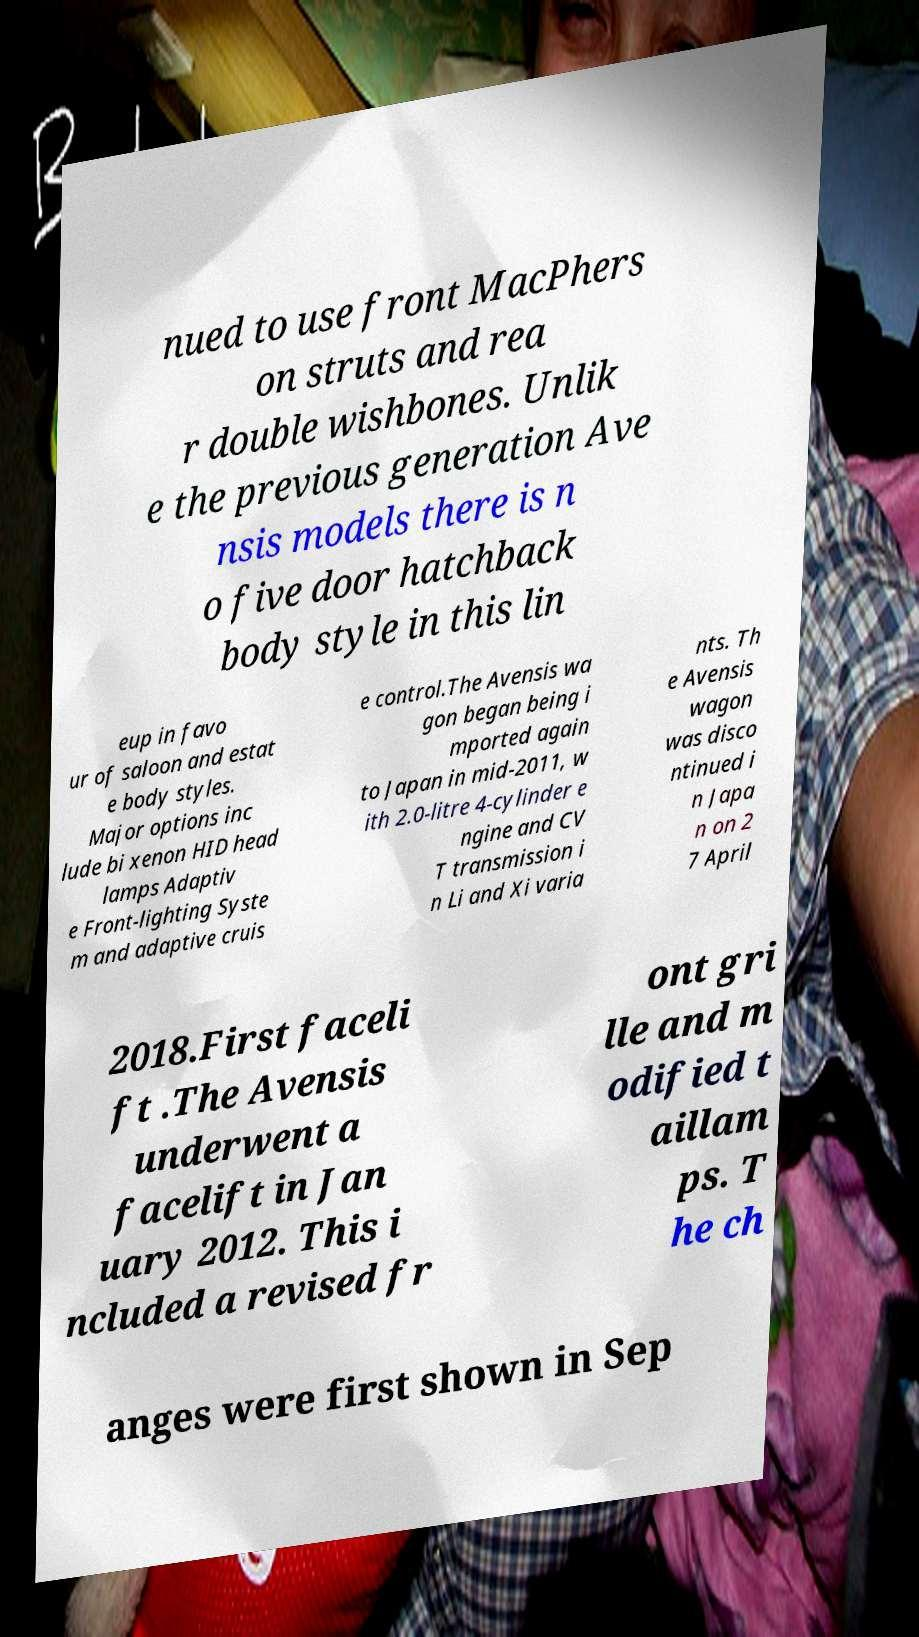Could you extract and type out the text from this image? nued to use front MacPhers on struts and rea r double wishbones. Unlik e the previous generation Ave nsis models there is n o five door hatchback body style in this lin eup in favo ur of saloon and estat e body styles. Major options inc lude bi xenon HID head lamps Adaptiv e Front-lighting Syste m and adaptive cruis e control.The Avensis wa gon began being i mported again to Japan in mid-2011, w ith 2.0-litre 4-cylinder e ngine and CV T transmission i n Li and Xi varia nts. Th e Avensis wagon was disco ntinued i n Japa n on 2 7 April 2018.First faceli ft .The Avensis underwent a facelift in Jan uary 2012. This i ncluded a revised fr ont gri lle and m odified t aillam ps. T he ch anges were first shown in Sep 